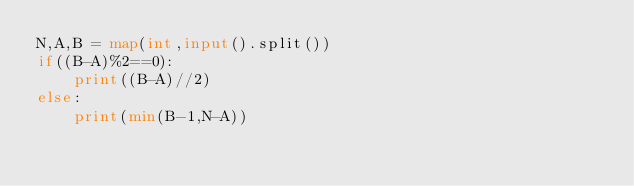<code> <loc_0><loc_0><loc_500><loc_500><_Python_>N,A,B = map(int,input().split())
if((B-A)%2==0):
    print((B-A)//2)
else:
    print(min(B-1,N-A))
</code> 